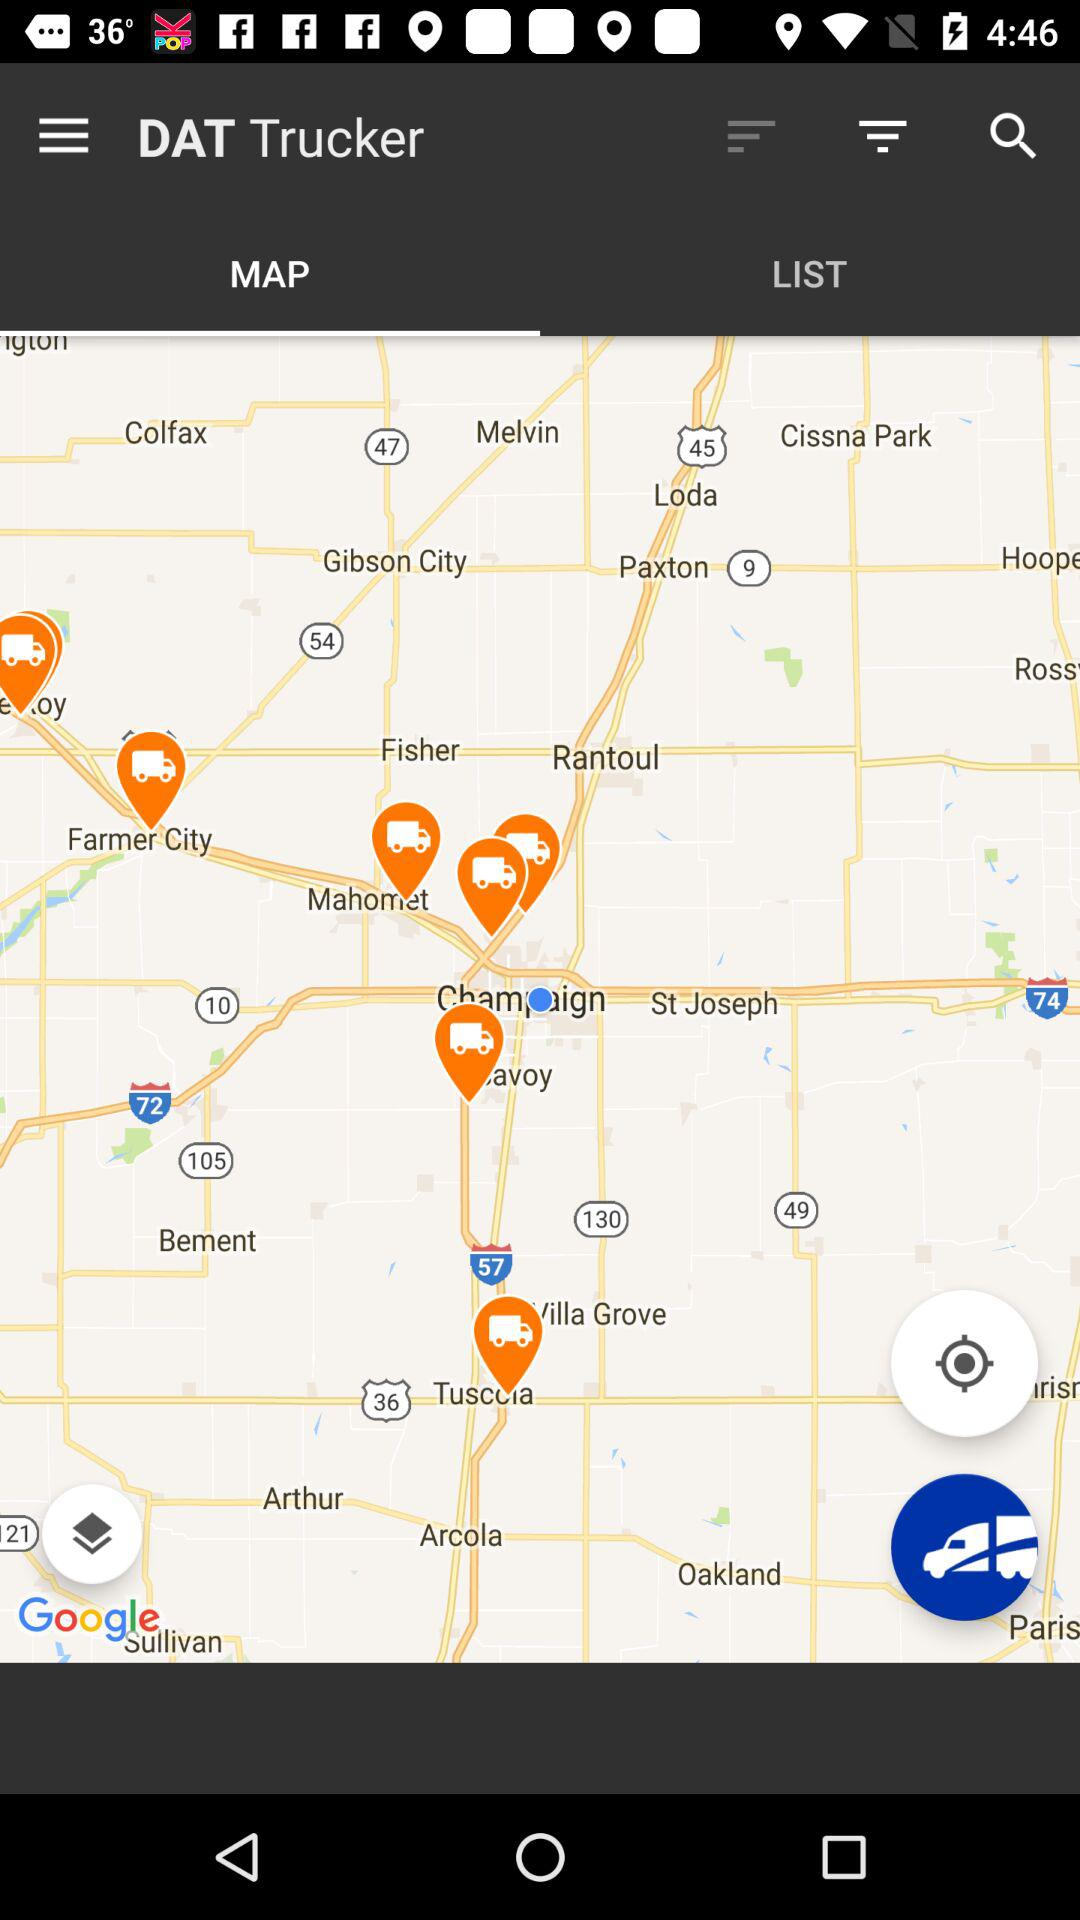How are the locations ordered in "LIST"?
When the provided information is insufficient, respond with <no answer>. <no answer> 